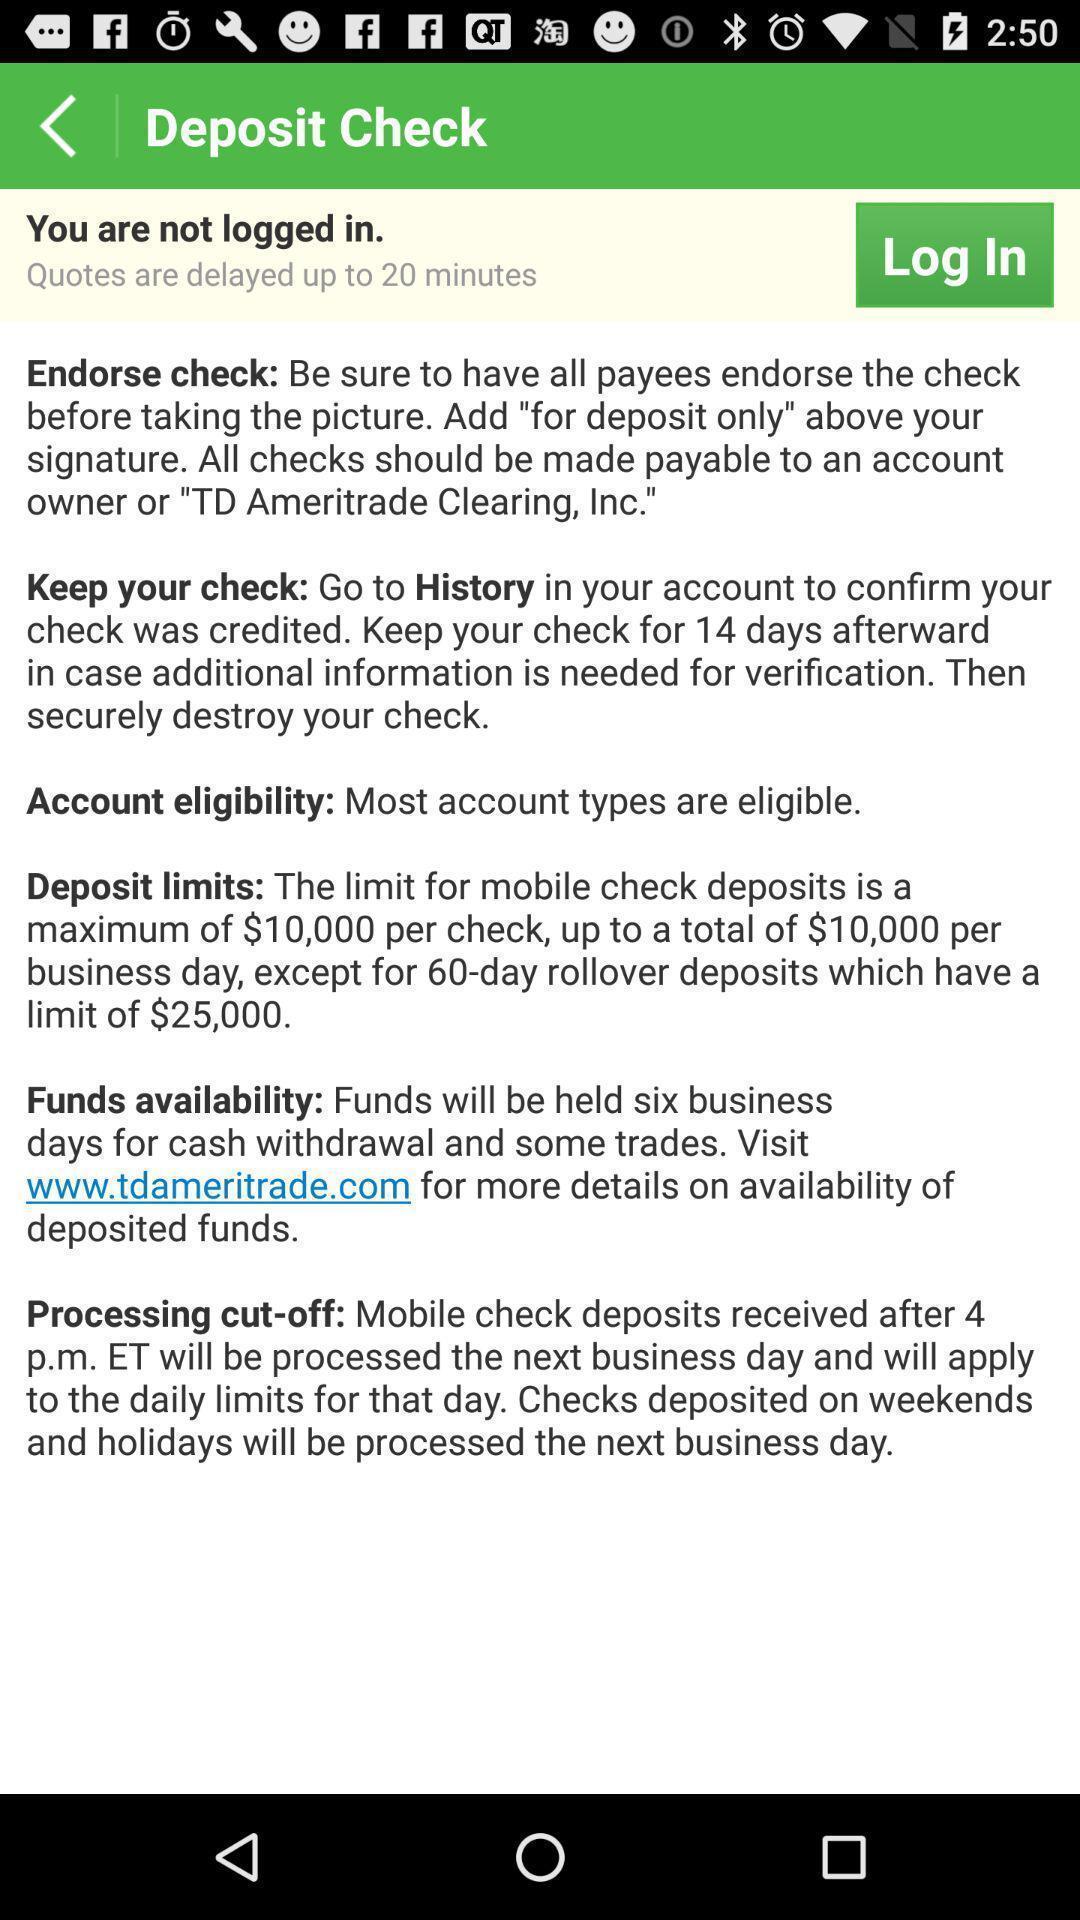Summarize the main components in this picture. Page shows information with login option in an financial application. 